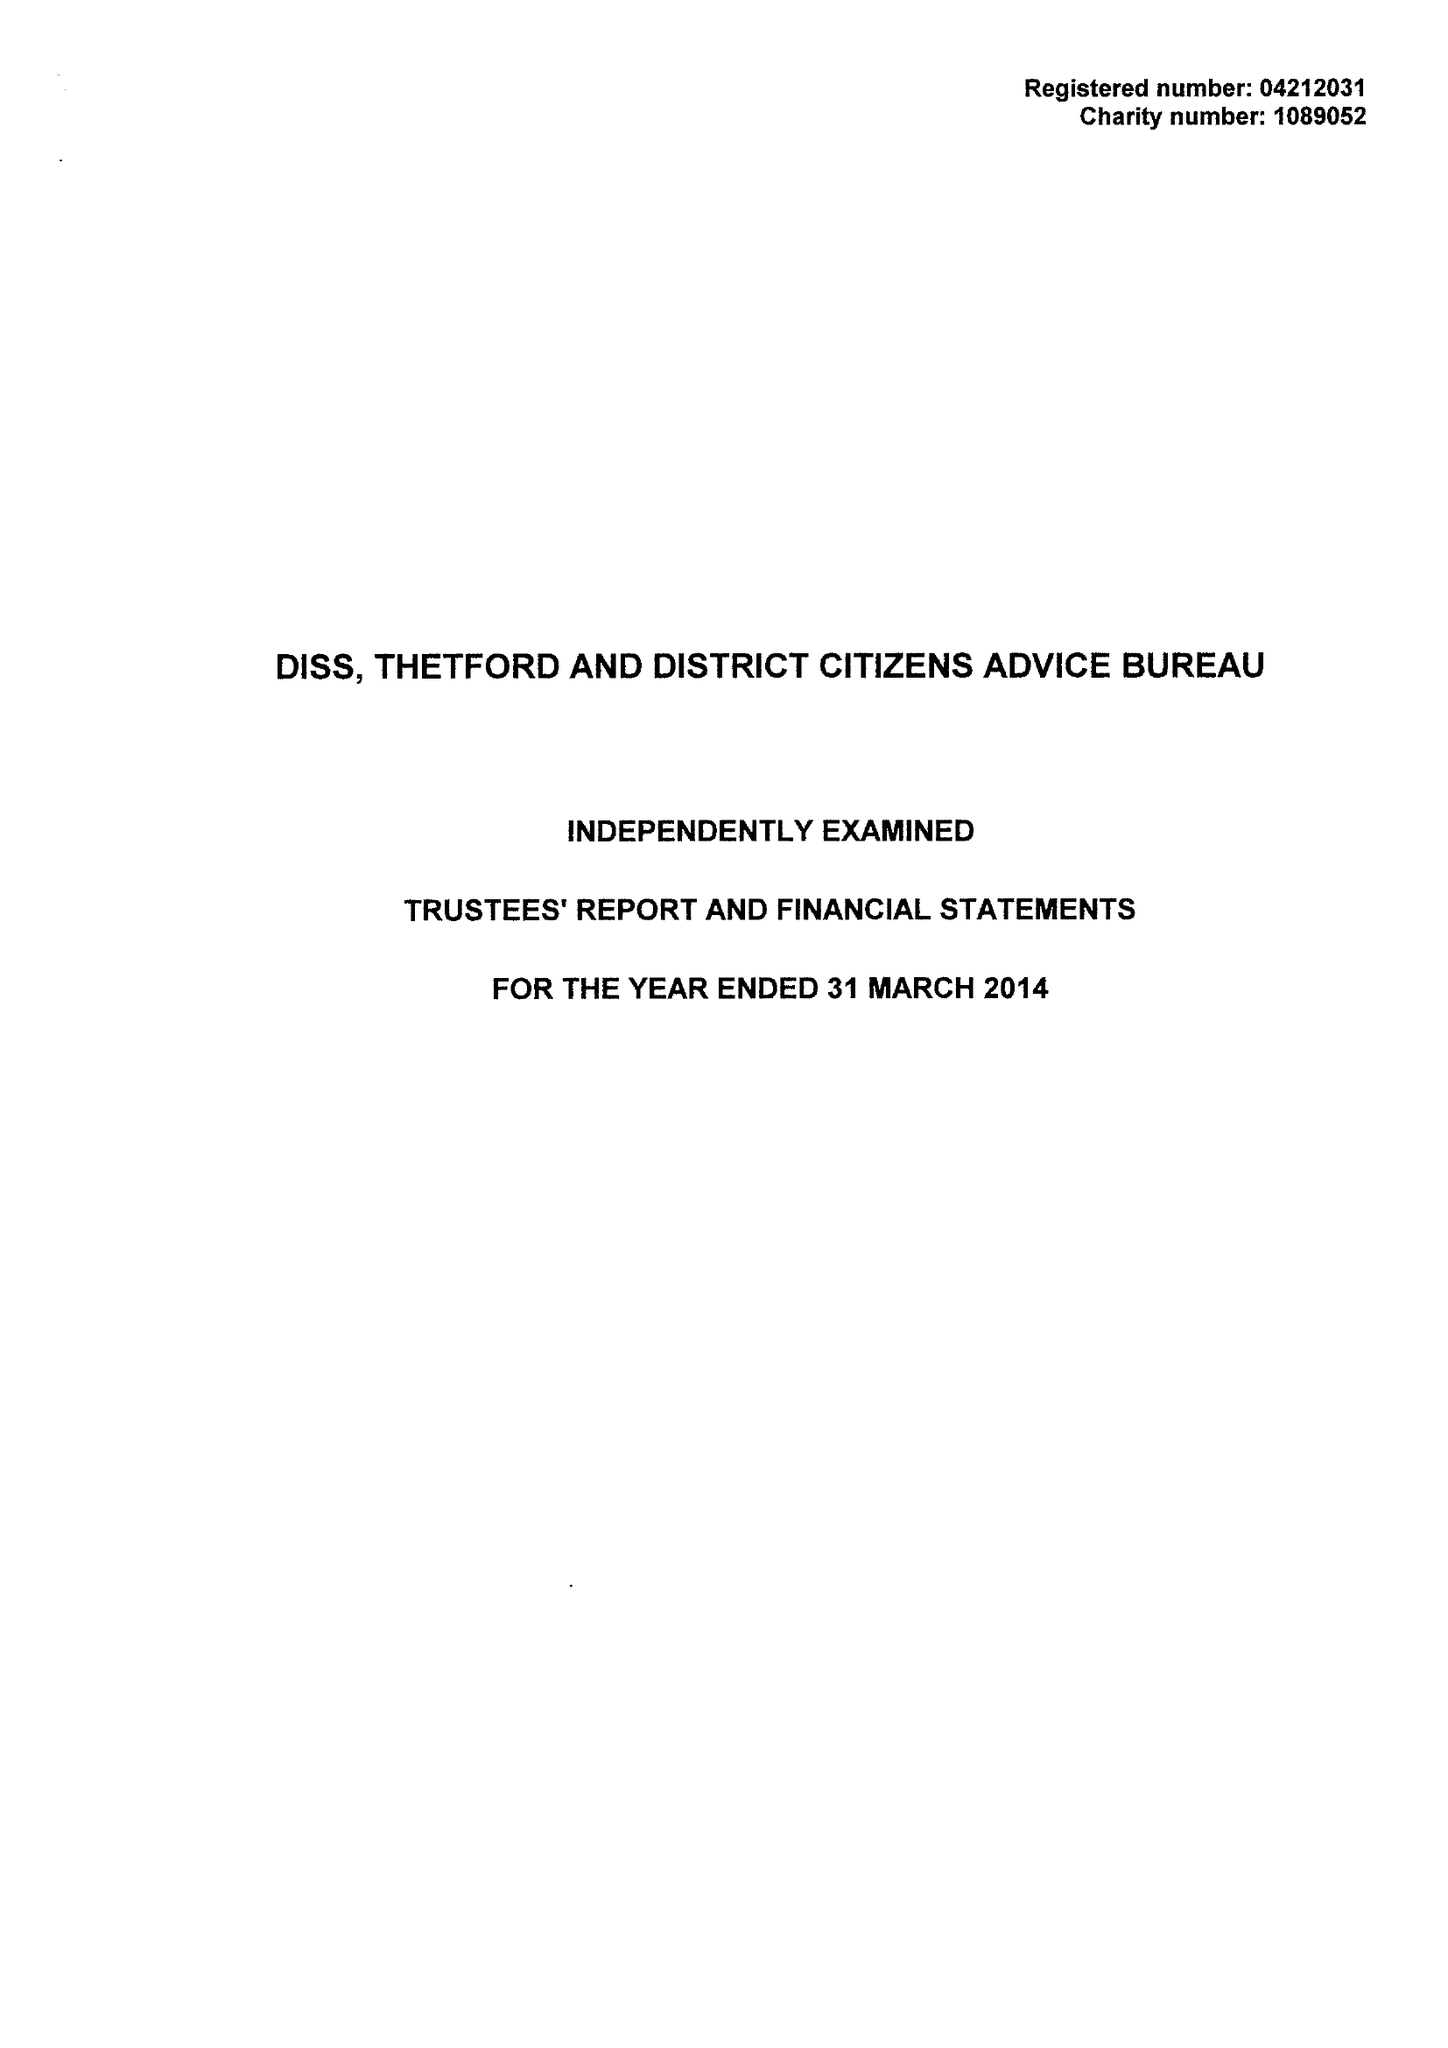What is the value for the address__street_line?
Answer the question using a single word or phrase. SHELFANGER ROAD 